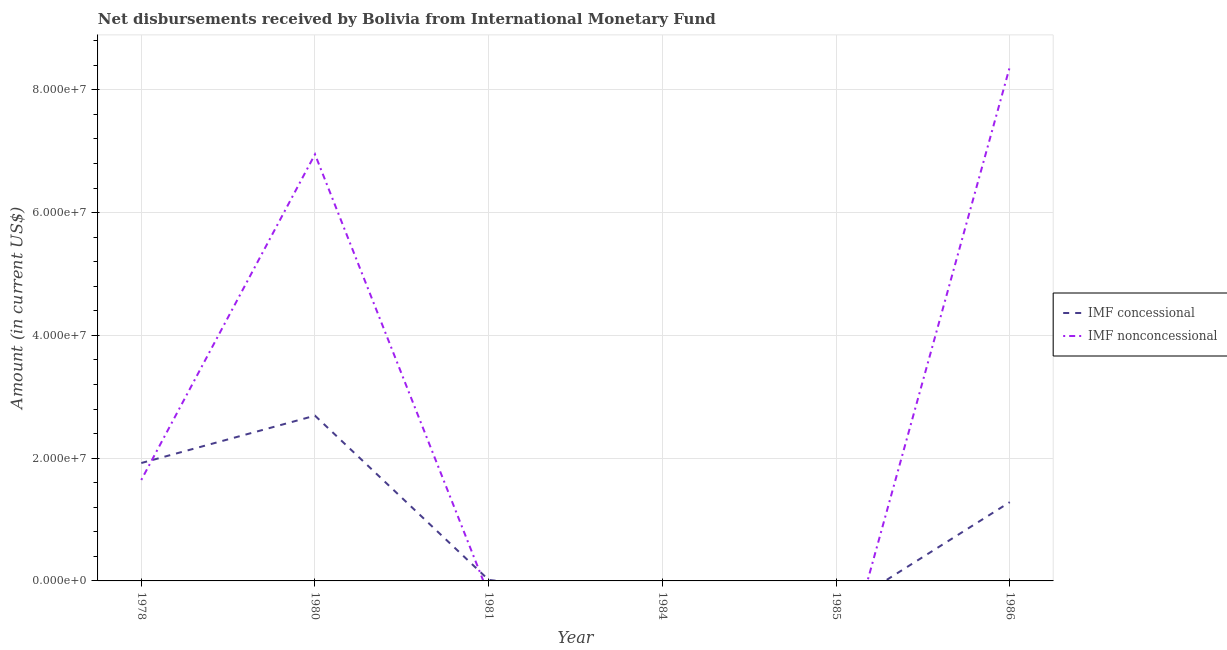What is the net non concessional disbursements from imf in 1986?
Your answer should be compact. 8.37e+07. Across all years, what is the maximum net non concessional disbursements from imf?
Your answer should be compact. 8.37e+07. Across all years, what is the minimum net non concessional disbursements from imf?
Provide a short and direct response. 0. In which year was the net non concessional disbursements from imf maximum?
Give a very brief answer. 1986. What is the total net non concessional disbursements from imf in the graph?
Ensure brevity in your answer.  1.70e+08. What is the difference between the net non concessional disbursements from imf in 1980 and that in 1986?
Make the answer very short. -1.42e+07. What is the difference between the net concessional disbursements from imf in 1980 and the net non concessional disbursements from imf in 1984?
Keep it short and to the point. 2.69e+07. What is the average net concessional disbursements from imf per year?
Your answer should be compact. 9.85e+06. In the year 1980, what is the difference between the net concessional disbursements from imf and net non concessional disbursements from imf?
Keep it short and to the point. -4.26e+07. In how many years, is the net concessional disbursements from imf greater than 12000000 US$?
Give a very brief answer. 3. What is the ratio of the net non concessional disbursements from imf in 1978 to that in 1986?
Make the answer very short. 0.2. What is the difference between the highest and the second highest net non concessional disbursements from imf?
Your answer should be compact. 1.42e+07. What is the difference between the highest and the lowest net non concessional disbursements from imf?
Offer a terse response. 8.37e+07. Does the net concessional disbursements from imf monotonically increase over the years?
Give a very brief answer. No. Is the net non concessional disbursements from imf strictly less than the net concessional disbursements from imf over the years?
Provide a short and direct response. No. How many lines are there?
Provide a succinct answer. 2. What is the difference between two consecutive major ticks on the Y-axis?
Offer a terse response. 2.00e+07. Where does the legend appear in the graph?
Offer a very short reply. Center right. How many legend labels are there?
Offer a terse response. 2. What is the title of the graph?
Ensure brevity in your answer.  Net disbursements received by Bolivia from International Monetary Fund. Does "Primary" appear as one of the legend labels in the graph?
Provide a short and direct response. No. What is the label or title of the X-axis?
Ensure brevity in your answer.  Year. What is the label or title of the Y-axis?
Offer a very short reply. Amount (in current US$). What is the Amount (in current US$) in IMF concessional in 1978?
Ensure brevity in your answer.  1.92e+07. What is the Amount (in current US$) in IMF nonconcessional in 1978?
Offer a terse response. 1.64e+07. What is the Amount (in current US$) in IMF concessional in 1980?
Your response must be concise. 2.69e+07. What is the Amount (in current US$) in IMF nonconcessional in 1980?
Ensure brevity in your answer.  6.95e+07. What is the Amount (in current US$) in IMF concessional in 1981?
Make the answer very short. 1.65e+05. What is the Amount (in current US$) in IMF nonconcessional in 1981?
Offer a terse response. 0. What is the Amount (in current US$) of IMF concessional in 1986?
Your response must be concise. 1.28e+07. What is the Amount (in current US$) in IMF nonconcessional in 1986?
Offer a terse response. 8.37e+07. Across all years, what is the maximum Amount (in current US$) of IMF concessional?
Your answer should be compact. 2.69e+07. Across all years, what is the maximum Amount (in current US$) of IMF nonconcessional?
Your answer should be very brief. 8.37e+07. Across all years, what is the minimum Amount (in current US$) in IMF concessional?
Your answer should be compact. 0. What is the total Amount (in current US$) of IMF concessional in the graph?
Your response must be concise. 5.91e+07. What is the total Amount (in current US$) of IMF nonconcessional in the graph?
Keep it short and to the point. 1.70e+08. What is the difference between the Amount (in current US$) of IMF concessional in 1978 and that in 1980?
Your answer should be very brief. -7.71e+06. What is the difference between the Amount (in current US$) in IMF nonconcessional in 1978 and that in 1980?
Keep it short and to the point. -5.31e+07. What is the difference between the Amount (in current US$) in IMF concessional in 1978 and that in 1981?
Give a very brief answer. 1.90e+07. What is the difference between the Amount (in current US$) in IMF concessional in 1978 and that in 1986?
Your answer should be very brief. 6.37e+06. What is the difference between the Amount (in current US$) of IMF nonconcessional in 1978 and that in 1986?
Your response must be concise. -6.73e+07. What is the difference between the Amount (in current US$) of IMF concessional in 1980 and that in 1981?
Keep it short and to the point. 2.68e+07. What is the difference between the Amount (in current US$) in IMF concessional in 1980 and that in 1986?
Provide a short and direct response. 1.41e+07. What is the difference between the Amount (in current US$) of IMF nonconcessional in 1980 and that in 1986?
Make the answer very short. -1.42e+07. What is the difference between the Amount (in current US$) of IMF concessional in 1981 and that in 1986?
Offer a very short reply. -1.27e+07. What is the difference between the Amount (in current US$) of IMF concessional in 1978 and the Amount (in current US$) of IMF nonconcessional in 1980?
Offer a very short reply. -5.03e+07. What is the difference between the Amount (in current US$) of IMF concessional in 1978 and the Amount (in current US$) of IMF nonconcessional in 1986?
Provide a short and direct response. -6.45e+07. What is the difference between the Amount (in current US$) of IMF concessional in 1980 and the Amount (in current US$) of IMF nonconcessional in 1986?
Offer a very short reply. -5.68e+07. What is the difference between the Amount (in current US$) of IMF concessional in 1981 and the Amount (in current US$) of IMF nonconcessional in 1986?
Make the answer very short. -8.36e+07. What is the average Amount (in current US$) of IMF concessional per year?
Offer a very short reply. 9.85e+06. What is the average Amount (in current US$) of IMF nonconcessional per year?
Make the answer very short. 2.83e+07. In the year 1978, what is the difference between the Amount (in current US$) of IMF concessional and Amount (in current US$) of IMF nonconcessional?
Ensure brevity in your answer.  2.76e+06. In the year 1980, what is the difference between the Amount (in current US$) of IMF concessional and Amount (in current US$) of IMF nonconcessional?
Your response must be concise. -4.26e+07. In the year 1986, what is the difference between the Amount (in current US$) of IMF concessional and Amount (in current US$) of IMF nonconcessional?
Ensure brevity in your answer.  -7.09e+07. What is the ratio of the Amount (in current US$) of IMF concessional in 1978 to that in 1980?
Your answer should be very brief. 0.71. What is the ratio of the Amount (in current US$) of IMF nonconcessional in 1978 to that in 1980?
Your answer should be compact. 0.24. What is the ratio of the Amount (in current US$) of IMF concessional in 1978 to that in 1981?
Ensure brevity in your answer.  116.41. What is the ratio of the Amount (in current US$) in IMF concessional in 1978 to that in 1986?
Ensure brevity in your answer.  1.5. What is the ratio of the Amount (in current US$) of IMF nonconcessional in 1978 to that in 1986?
Your response must be concise. 0.2. What is the ratio of the Amount (in current US$) in IMF concessional in 1980 to that in 1981?
Offer a terse response. 163.16. What is the ratio of the Amount (in current US$) in IMF concessional in 1980 to that in 1986?
Offer a terse response. 2.1. What is the ratio of the Amount (in current US$) of IMF nonconcessional in 1980 to that in 1986?
Ensure brevity in your answer.  0.83. What is the ratio of the Amount (in current US$) in IMF concessional in 1981 to that in 1986?
Your answer should be compact. 0.01. What is the difference between the highest and the second highest Amount (in current US$) of IMF concessional?
Give a very brief answer. 7.71e+06. What is the difference between the highest and the second highest Amount (in current US$) in IMF nonconcessional?
Provide a short and direct response. 1.42e+07. What is the difference between the highest and the lowest Amount (in current US$) of IMF concessional?
Provide a succinct answer. 2.69e+07. What is the difference between the highest and the lowest Amount (in current US$) in IMF nonconcessional?
Make the answer very short. 8.37e+07. 